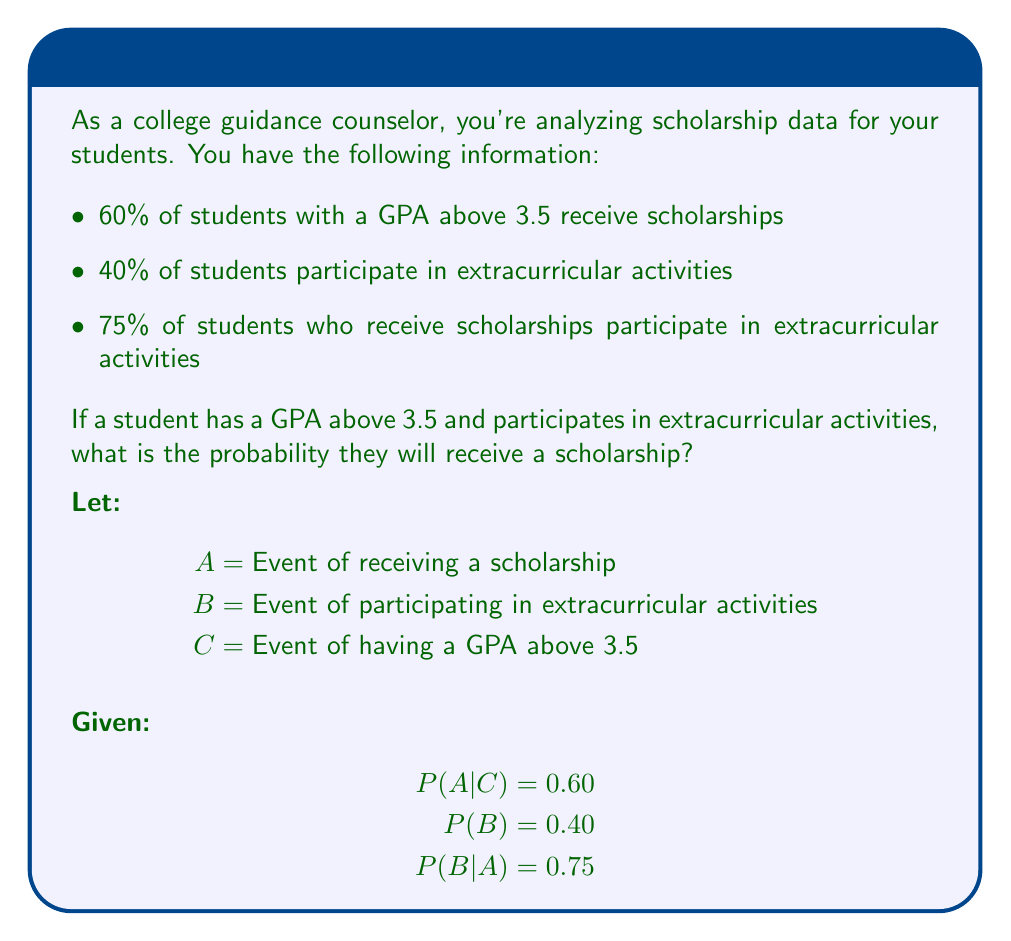Provide a solution to this math problem. To solve this problem, we need to use Bayes' theorem and the law of total probability. We want to find $P(A|B,C)$.

Step 1: Use Bayes' theorem
$$P(A|B,C) = \frac{P(B|A,C) \cdot P(A|C)}{P(B|C)}$$

Step 2: We know $P(A|C) = 0.60$, but we need to find $P(B|A,C)$ and $P(B|C)$.

Step 3: Assume $B$ and $C$ are independent events. Then $P(B|A,C) = P(B|A) = 0.75$.

Step 4: To find $P(B|C)$, use the law of total probability:
$$P(B|C) = P(B|A,C) \cdot P(A|C) + P(B|\neg A,C) \cdot P(\neg A|C)$$

Step 5: We know $P(B|A,C) = 0.75$, $P(A|C) = 0.60$, and $P(\neg A|C) = 1 - 0.60 = 0.40$.
We need to find $P(B|\neg A,C)$:

$$P(B) = P(B|A) \cdot P(A) + P(B|\neg A) \cdot P(\neg A)$$
$$0.40 = 0.75 \cdot 0.60 \cdot P(C) + P(B|\neg A) \cdot (1 - 0.60 \cdot P(C))$$

Assuming $P(C) = 0.50$ (half of students have GPA above 3.5), we get:
$$P(B|\neg A) \approx 0.25$$

Step 6: Now we can calculate $P(B|C)$:
$$P(B|C) = 0.75 \cdot 0.60 + 0.25 \cdot 0.40 = 0.55$$

Step 7: Finally, we can use Bayes' theorem:
$$P(A|B,C) = \frac{0.75 \cdot 0.60}{0.55} \approx 0.8182$$
Answer: $P(A|B,C) \approx 0.8182$ or about $81.82\%$ 